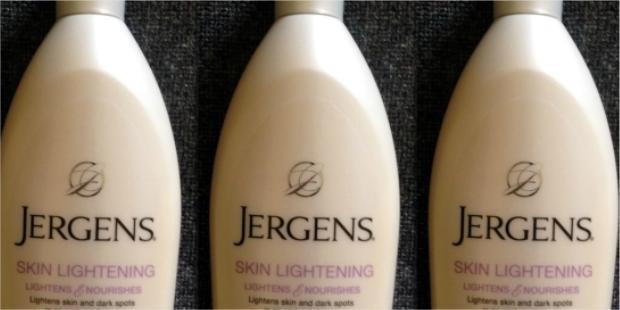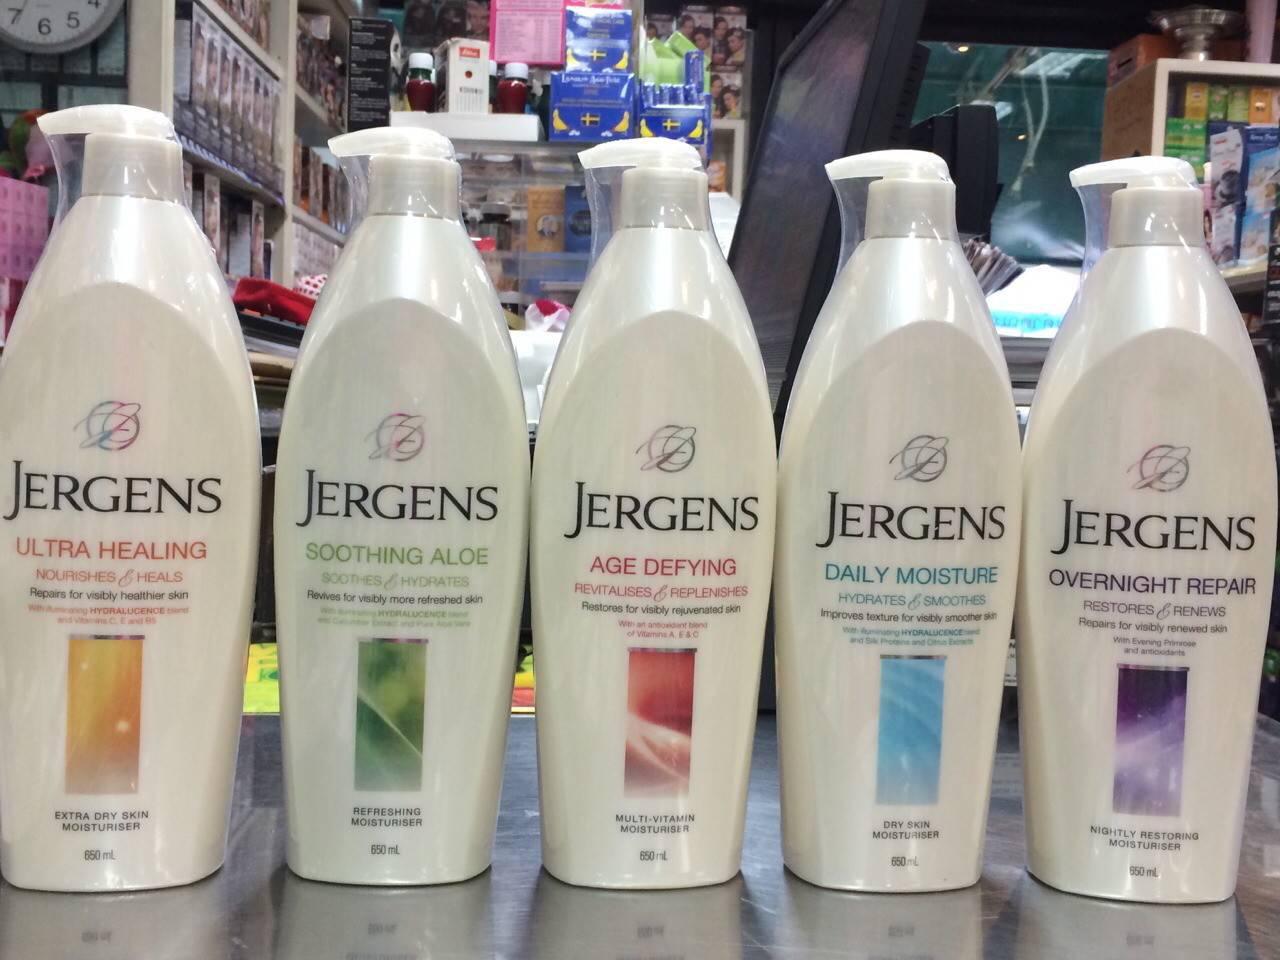The first image is the image on the left, the second image is the image on the right. Examine the images to the left and right. Is the description "No more than three lotion bottles are visible in the left image." accurate? Answer yes or no. Yes. 